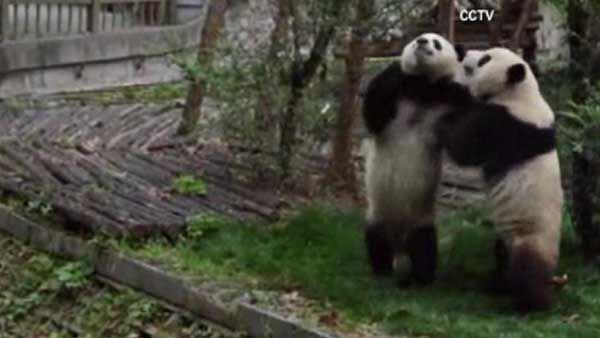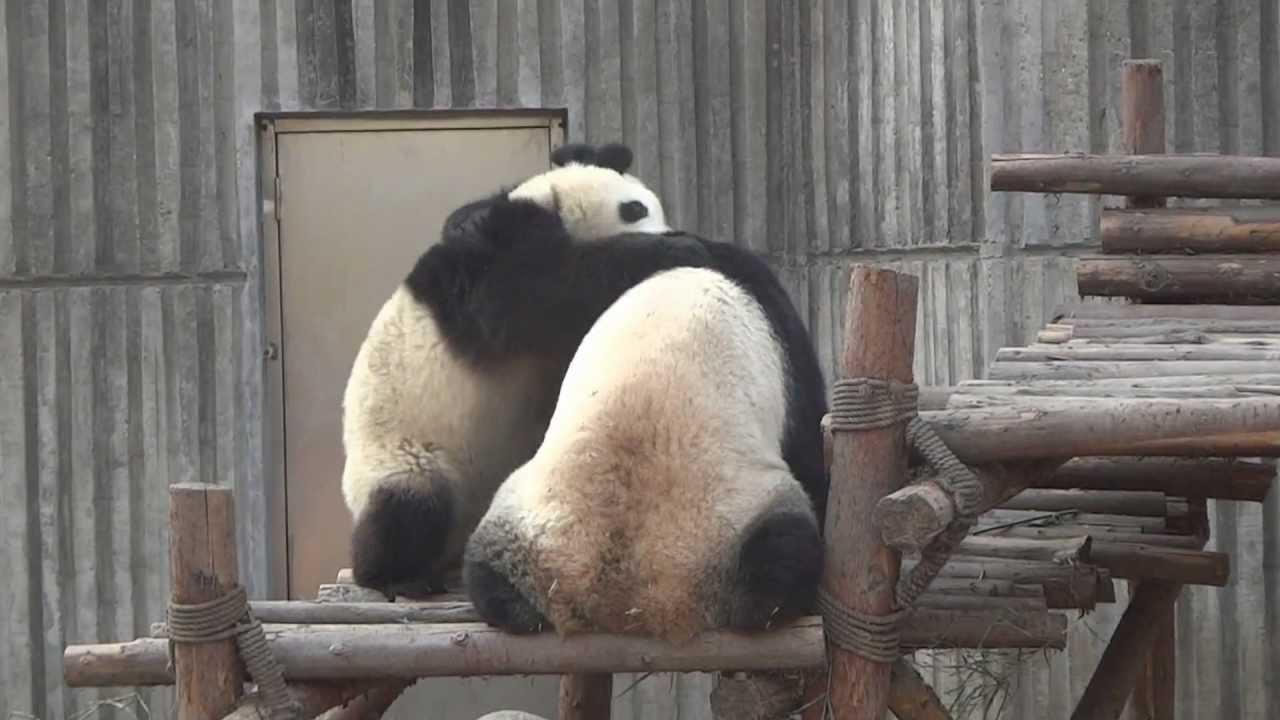The first image is the image on the left, the second image is the image on the right. Considering the images on both sides, is "There are four pandas" valid? Answer yes or no. Yes. The first image is the image on the left, the second image is the image on the right. Considering the images on both sides, is "One image shows two pandas, and the one on the left is standing on a log platform with an arm around the back-turned panda on the right." valid? Answer yes or no. Yes. 